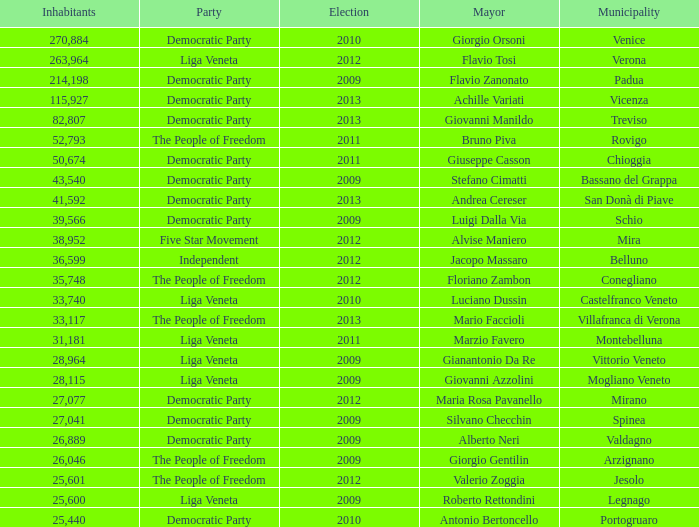How many elections had a population exceeding 36,599 when mayor was giovanni manildo? 1.0. 